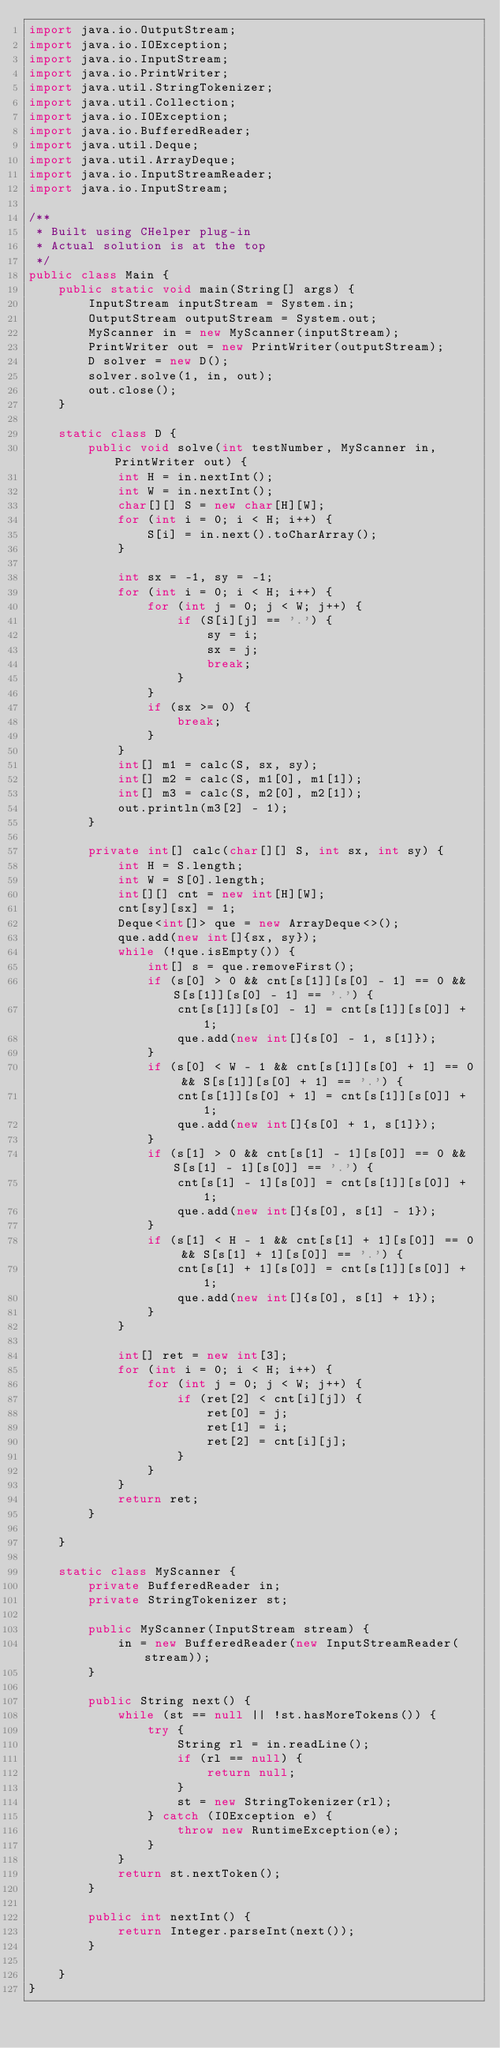Convert code to text. <code><loc_0><loc_0><loc_500><loc_500><_Java_>import java.io.OutputStream;
import java.io.IOException;
import java.io.InputStream;
import java.io.PrintWriter;
import java.util.StringTokenizer;
import java.util.Collection;
import java.io.IOException;
import java.io.BufferedReader;
import java.util.Deque;
import java.util.ArrayDeque;
import java.io.InputStreamReader;
import java.io.InputStream;

/**
 * Built using CHelper plug-in
 * Actual solution is at the top
 */
public class Main {
    public static void main(String[] args) {
        InputStream inputStream = System.in;
        OutputStream outputStream = System.out;
        MyScanner in = new MyScanner(inputStream);
        PrintWriter out = new PrintWriter(outputStream);
        D solver = new D();
        solver.solve(1, in, out);
        out.close();
    }

    static class D {
        public void solve(int testNumber, MyScanner in, PrintWriter out) {
            int H = in.nextInt();
            int W = in.nextInt();
            char[][] S = new char[H][W];
            for (int i = 0; i < H; i++) {
                S[i] = in.next().toCharArray();
            }

            int sx = -1, sy = -1;
            for (int i = 0; i < H; i++) {
                for (int j = 0; j < W; j++) {
                    if (S[i][j] == '.') {
                        sy = i;
                        sx = j;
                        break;
                    }
                }
                if (sx >= 0) {
                    break;
                }
            }
            int[] m1 = calc(S, sx, sy);
            int[] m2 = calc(S, m1[0], m1[1]);
            int[] m3 = calc(S, m2[0], m2[1]);
            out.println(m3[2] - 1);
        }

        private int[] calc(char[][] S, int sx, int sy) {
            int H = S.length;
            int W = S[0].length;
            int[][] cnt = new int[H][W];
            cnt[sy][sx] = 1;
            Deque<int[]> que = new ArrayDeque<>();
            que.add(new int[]{sx, sy});
            while (!que.isEmpty()) {
                int[] s = que.removeFirst();
                if (s[0] > 0 && cnt[s[1]][s[0] - 1] == 0 && S[s[1]][s[0] - 1] == '.') {
                    cnt[s[1]][s[0] - 1] = cnt[s[1]][s[0]] + 1;
                    que.add(new int[]{s[0] - 1, s[1]});
                }
                if (s[0] < W - 1 && cnt[s[1]][s[0] + 1] == 0 && S[s[1]][s[0] + 1] == '.') {
                    cnt[s[1]][s[0] + 1] = cnt[s[1]][s[0]] + 1;
                    que.add(new int[]{s[0] + 1, s[1]});
                }
                if (s[1] > 0 && cnt[s[1] - 1][s[0]] == 0 && S[s[1] - 1][s[0]] == '.') {
                    cnt[s[1] - 1][s[0]] = cnt[s[1]][s[0]] + 1;
                    que.add(new int[]{s[0], s[1] - 1});
                }
                if (s[1] < H - 1 && cnt[s[1] + 1][s[0]] == 0 && S[s[1] + 1][s[0]] == '.') {
                    cnt[s[1] + 1][s[0]] = cnt[s[1]][s[0]] + 1;
                    que.add(new int[]{s[0], s[1] + 1});
                }
            }

            int[] ret = new int[3];
            for (int i = 0; i < H; i++) {
                for (int j = 0; j < W; j++) {
                    if (ret[2] < cnt[i][j]) {
                        ret[0] = j;
                        ret[1] = i;
                        ret[2] = cnt[i][j];
                    }
                }
            }
            return ret;
        }

    }

    static class MyScanner {
        private BufferedReader in;
        private StringTokenizer st;

        public MyScanner(InputStream stream) {
            in = new BufferedReader(new InputStreamReader(stream));
        }

        public String next() {
            while (st == null || !st.hasMoreTokens()) {
                try {
                    String rl = in.readLine();
                    if (rl == null) {
                        return null;
                    }
                    st = new StringTokenizer(rl);
                } catch (IOException e) {
                    throw new RuntimeException(e);
                }
            }
            return st.nextToken();
        }

        public int nextInt() {
            return Integer.parseInt(next());
        }

    }
}

</code> 